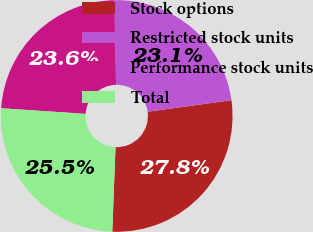Convert chart. <chart><loc_0><loc_0><loc_500><loc_500><pie_chart><fcel>Stock options<fcel>Restricted stock units<fcel>Performance stock units<fcel>Total<nl><fcel>27.78%<fcel>23.15%<fcel>23.61%<fcel>25.46%<nl></chart> 